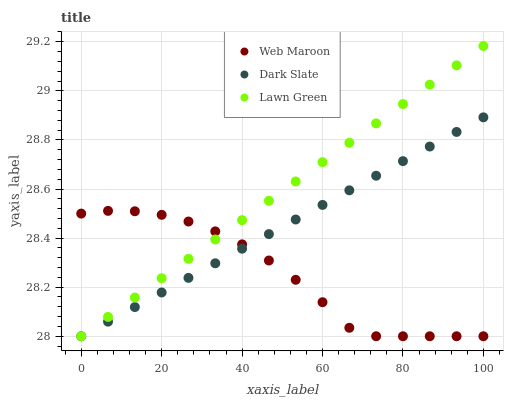Does Web Maroon have the minimum area under the curve?
Answer yes or no. Yes. Does Lawn Green have the maximum area under the curve?
Answer yes or no. Yes. Does Lawn Green have the minimum area under the curve?
Answer yes or no. No. Does Web Maroon have the maximum area under the curve?
Answer yes or no. No. Is Lawn Green the smoothest?
Answer yes or no. Yes. Is Web Maroon the roughest?
Answer yes or no. Yes. Is Web Maroon the smoothest?
Answer yes or no. No. Is Lawn Green the roughest?
Answer yes or no. No. Does Dark Slate have the lowest value?
Answer yes or no. Yes. Does Lawn Green have the highest value?
Answer yes or no. Yes. Does Web Maroon have the highest value?
Answer yes or no. No. Does Web Maroon intersect Dark Slate?
Answer yes or no. Yes. Is Web Maroon less than Dark Slate?
Answer yes or no. No. Is Web Maroon greater than Dark Slate?
Answer yes or no. No. 